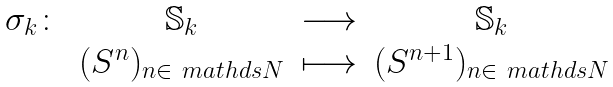Convert formula to latex. <formula><loc_0><loc_0><loc_500><loc_500>\begin{array} { c c c c } \sigma _ { k } \colon & \mathbb { S } _ { k } & \longrightarrow & \mathbb { S } _ { k } \\ & ( S ^ { n } ) _ { n \in \ m a t h d s { N } } & \longmapsto & ( S ^ { n + 1 } ) _ { n \in \ m a t h d s { N } } \end{array}</formula> 